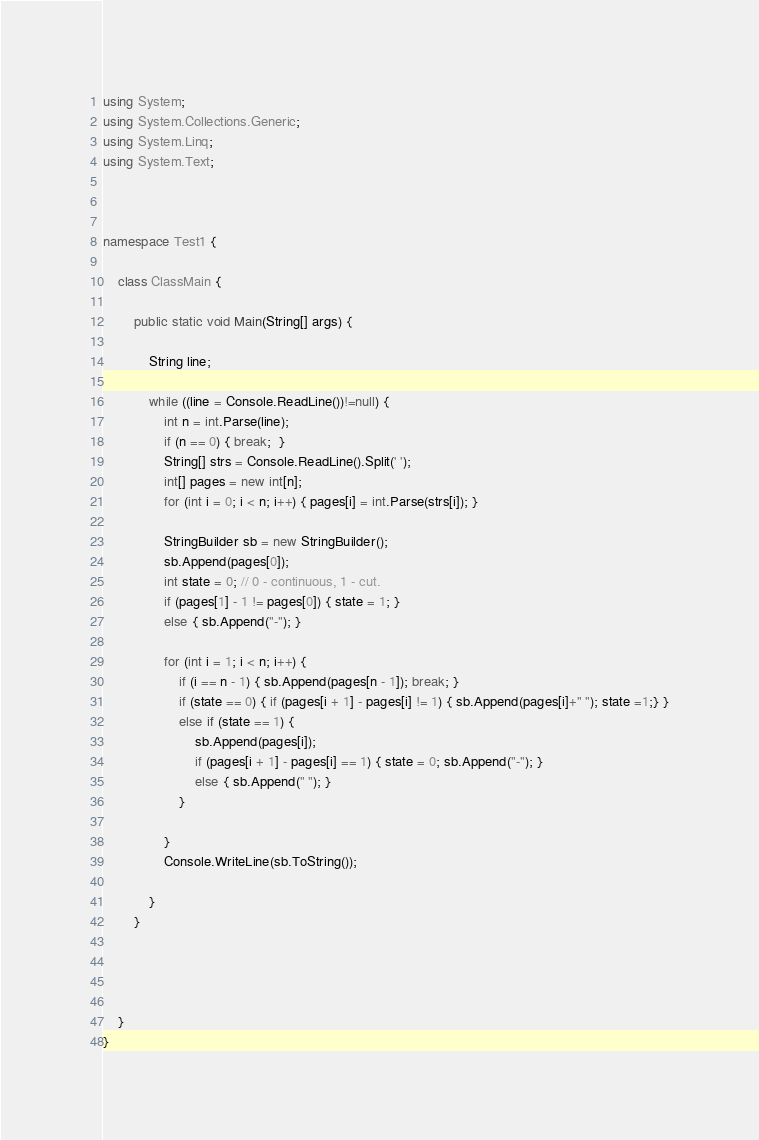Convert code to text. <code><loc_0><loc_0><loc_500><loc_500><_C#_>using System;
using System.Collections.Generic;
using System.Linq;
using System.Text;



namespace Test1 {

    class ClassMain {

        public static void Main(String[] args) {

            String line;
                
            while ((line = Console.ReadLine())!=null) {
                int n = int.Parse(line);
                if (n == 0) { break;  }
                String[] strs = Console.ReadLine().Split(' ');
                int[] pages = new int[n];
                for (int i = 0; i < n; i++) { pages[i] = int.Parse(strs[i]); }
                
                StringBuilder sb = new StringBuilder();
                sb.Append(pages[0]);
                int state = 0; // 0 - continuous, 1 - cut.
                if (pages[1] - 1 != pages[0]) { state = 1; }
                else { sb.Append("-"); }
 
                for (int i = 1; i < n; i++) {
                    if (i == n - 1) { sb.Append(pages[n - 1]); break; }
                    if (state == 0) { if (pages[i + 1] - pages[i] != 1) { sb.Append(pages[i]+" "); state =1;} }
                    else if (state == 1) { 
                        sb.Append(pages[i]);
                        if (pages[i + 1] - pages[i] == 1) { state = 0; sb.Append("-"); }
                        else { sb.Append(" "); }
                    }
                
                }
                Console.WriteLine(sb.ToString());

            }
        }

        
        
        
    }
}</code> 